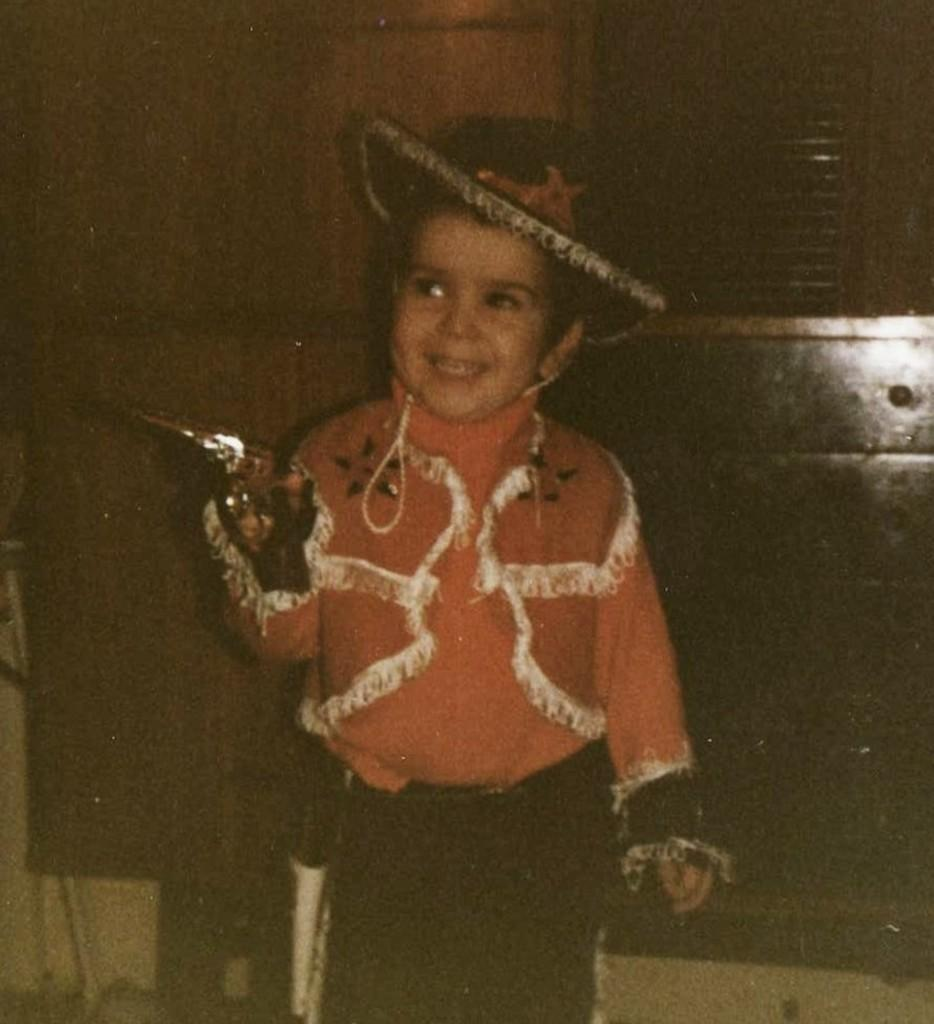What is the main subject of the image? The main subject of the image is a kid. Where is the kid located in relation to the wall? The kid is in front of a wall. What is the kid wearing? The kid is wearing clothes and a hat. What can be seen in the top right corner of the image? There is a window in the top right corner of the image. What type of farm can be seen in the background of the image? There is no farm visible in the image; it only features a kid in front of a wall, wearing clothes and a hat, with a window in the top right corner. 